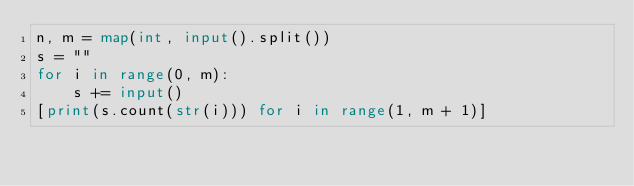Convert code to text. <code><loc_0><loc_0><loc_500><loc_500><_Python_>n, m = map(int, input().split())
s = ""
for i in range(0, m):
    s += input()
[print(s.count(str(i))) for i in range(1, m + 1)]
</code> 